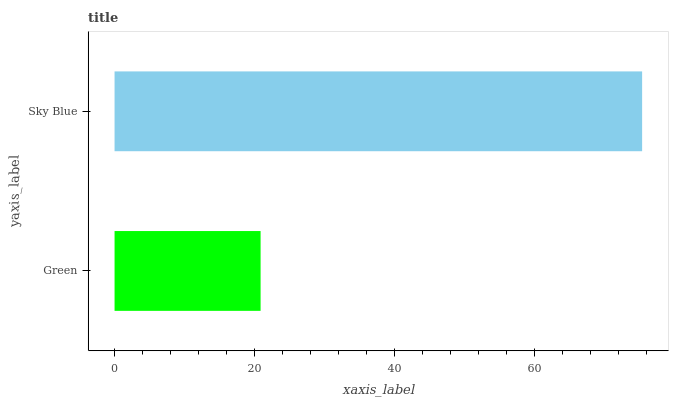Is Green the minimum?
Answer yes or no. Yes. Is Sky Blue the maximum?
Answer yes or no. Yes. Is Sky Blue the minimum?
Answer yes or no. No. Is Sky Blue greater than Green?
Answer yes or no. Yes. Is Green less than Sky Blue?
Answer yes or no. Yes. Is Green greater than Sky Blue?
Answer yes or no. No. Is Sky Blue less than Green?
Answer yes or no. No. Is Sky Blue the high median?
Answer yes or no. Yes. Is Green the low median?
Answer yes or no. Yes. Is Green the high median?
Answer yes or no. No. Is Sky Blue the low median?
Answer yes or no. No. 